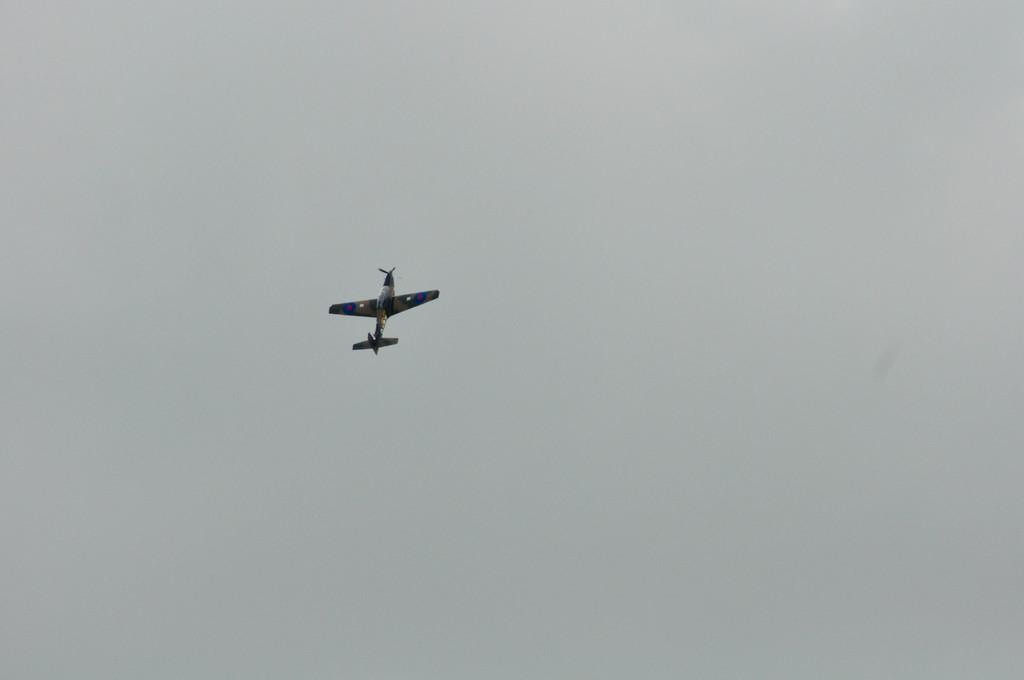What is the main subject of the image? The main subject of the image is an aircraft. What colors can be seen on the aircraft? The aircraft is yellow, blue, and black in color. What is the aircraft doing in the image? The aircraft is flying in the air. What can be seen in the background of the image? The sky is visible in the background of the image. What type of chess piece is depicted on the aircraft's wing in the image? There is no chess piece depicted on the aircraft's wing in the image. How does the party affect the aircraft's speed in the image? There is no party mentioned or depicted in the image, so its effect on the aircraft's speed cannot be determined. 